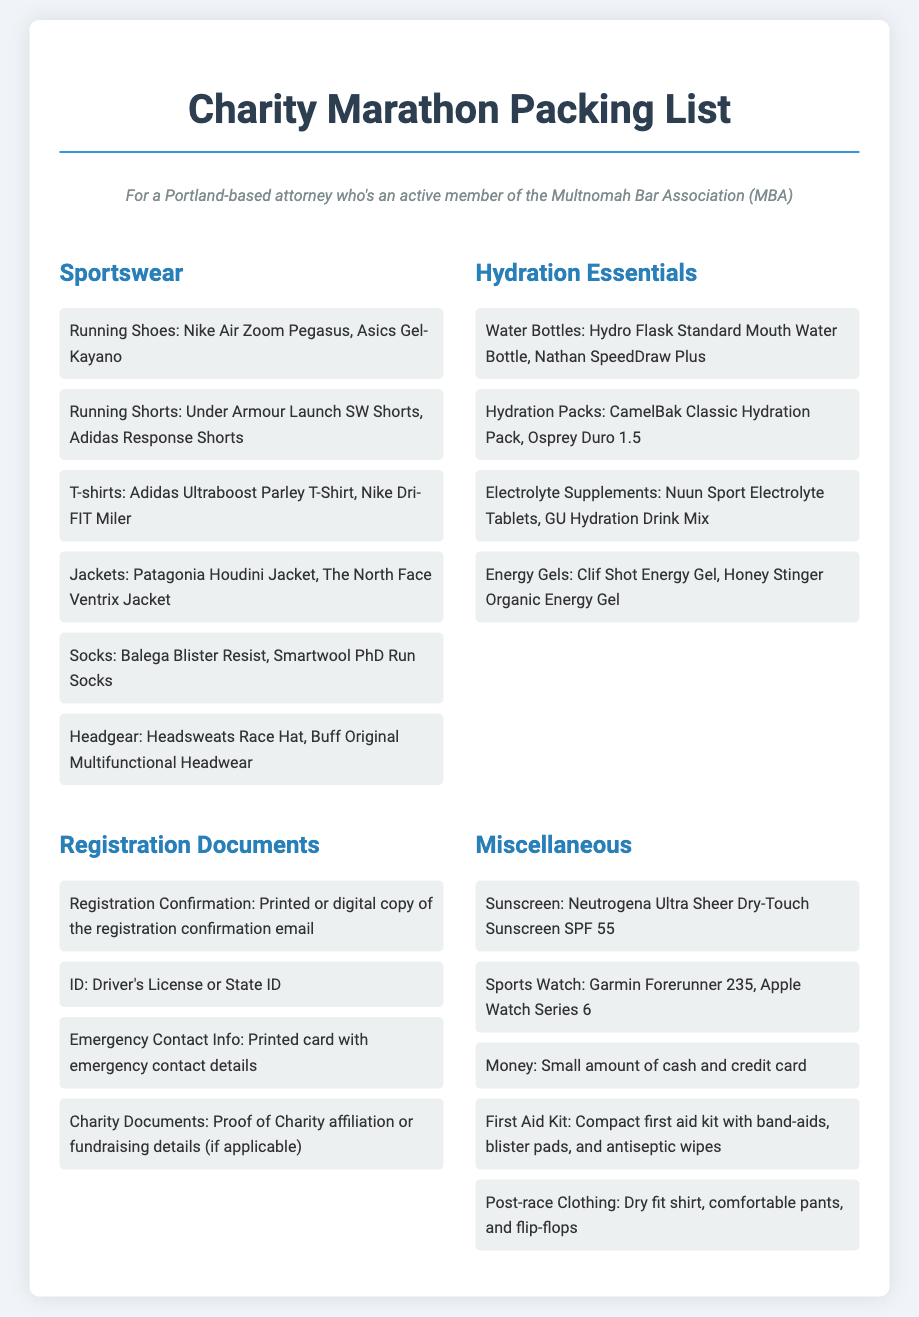what types of shoes are recommended? The document lists specific brands of running shoes suitable for the marathon.
Answer: Nike Air Zoom Pegasus, Asics Gel-Kayano what hydration packs are mentioned? The packing list specifies particular hydration packs recommended for participants.
Answer: CamelBak Classic Hydration Pack, Osprey Duro 1.5 how many documents are required for registration? The packing list outlines the necessary registration documents for participation in the marathon.
Answer: Four what is included in the miscellaneous section? The document has a specific category for miscellaneous items needed for the marathon, detailing essential items.
Answer: Sunscreen, Sports Watch, Money, First Aid Kit, Post-race Clothing which item is suggested for sun protection? The packing list provides a specific sunscreen brand as the recommended sun protection.
Answer: Neutrogena Ultra Sheer Dry-Touch Sunscreen SPF 55 what type of contact information should be printed? The document notes that emergency contact details need to be printed for the event.
Answer: Emergency Contact Info which category includes running shorts? The packing list categorizes items into specific sections, indicating where running shorts are found.
Answer: Sportswear how many energy gels are listed? The document specifies the types of energy gels that participants can bring for hydration and energy.
Answer: Two 